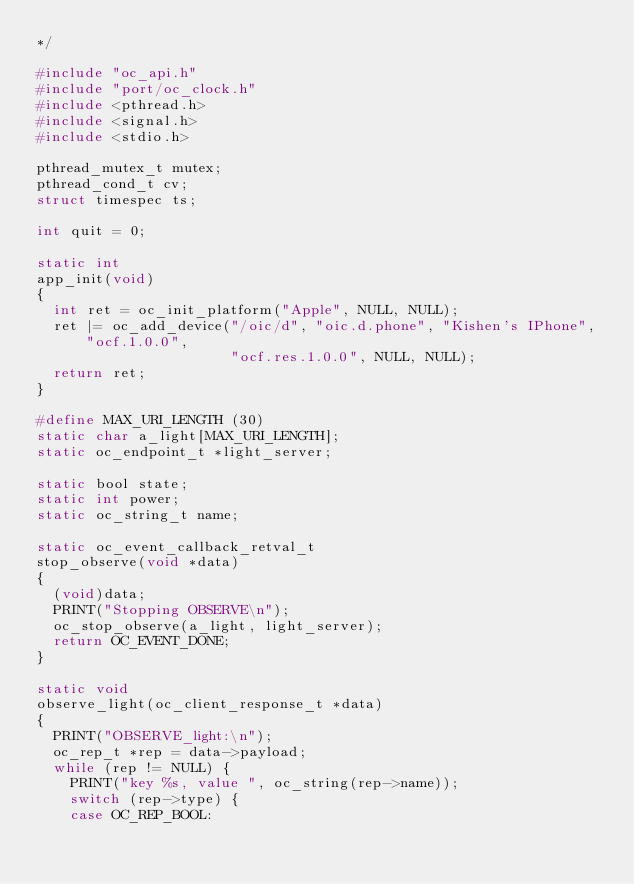Convert code to text. <code><loc_0><loc_0><loc_500><loc_500><_C_>*/

#include "oc_api.h"
#include "port/oc_clock.h"
#include <pthread.h>
#include <signal.h>
#include <stdio.h>

pthread_mutex_t mutex;
pthread_cond_t cv;
struct timespec ts;

int quit = 0;

static int
app_init(void)
{
  int ret = oc_init_platform("Apple", NULL, NULL);
  ret |= oc_add_device("/oic/d", "oic.d.phone", "Kishen's IPhone", "ocf.1.0.0",
                       "ocf.res.1.0.0", NULL, NULL);
  return ret;
}

#define MAX_URI_LENGTH (30)
static char a_light[MAX_URI_LENGTH];
static oc_endpoint_t *light_server;

static bool state;
static int power;
static oc_string_t name;

static oc_event_callback_retval_t
stop_observe(void *data)
{
  (void)data;
  PRINT("Stopping OBSERVE\n");
  oc_stop_observe(a_light, light_server);
  return OC_EVENT_DONE;
}

static void
observe_light(oc_client_response_t *data)
{
  PRINT("OBSERVE_light:\n");
  oc_rep_t *rep = data->payload;
  while (rep != NULL) {
    PRINT("key %s, value ", oc_string(rep->name));
    switch (rep->type) {
    case OC_REP_BOOL:</code> 